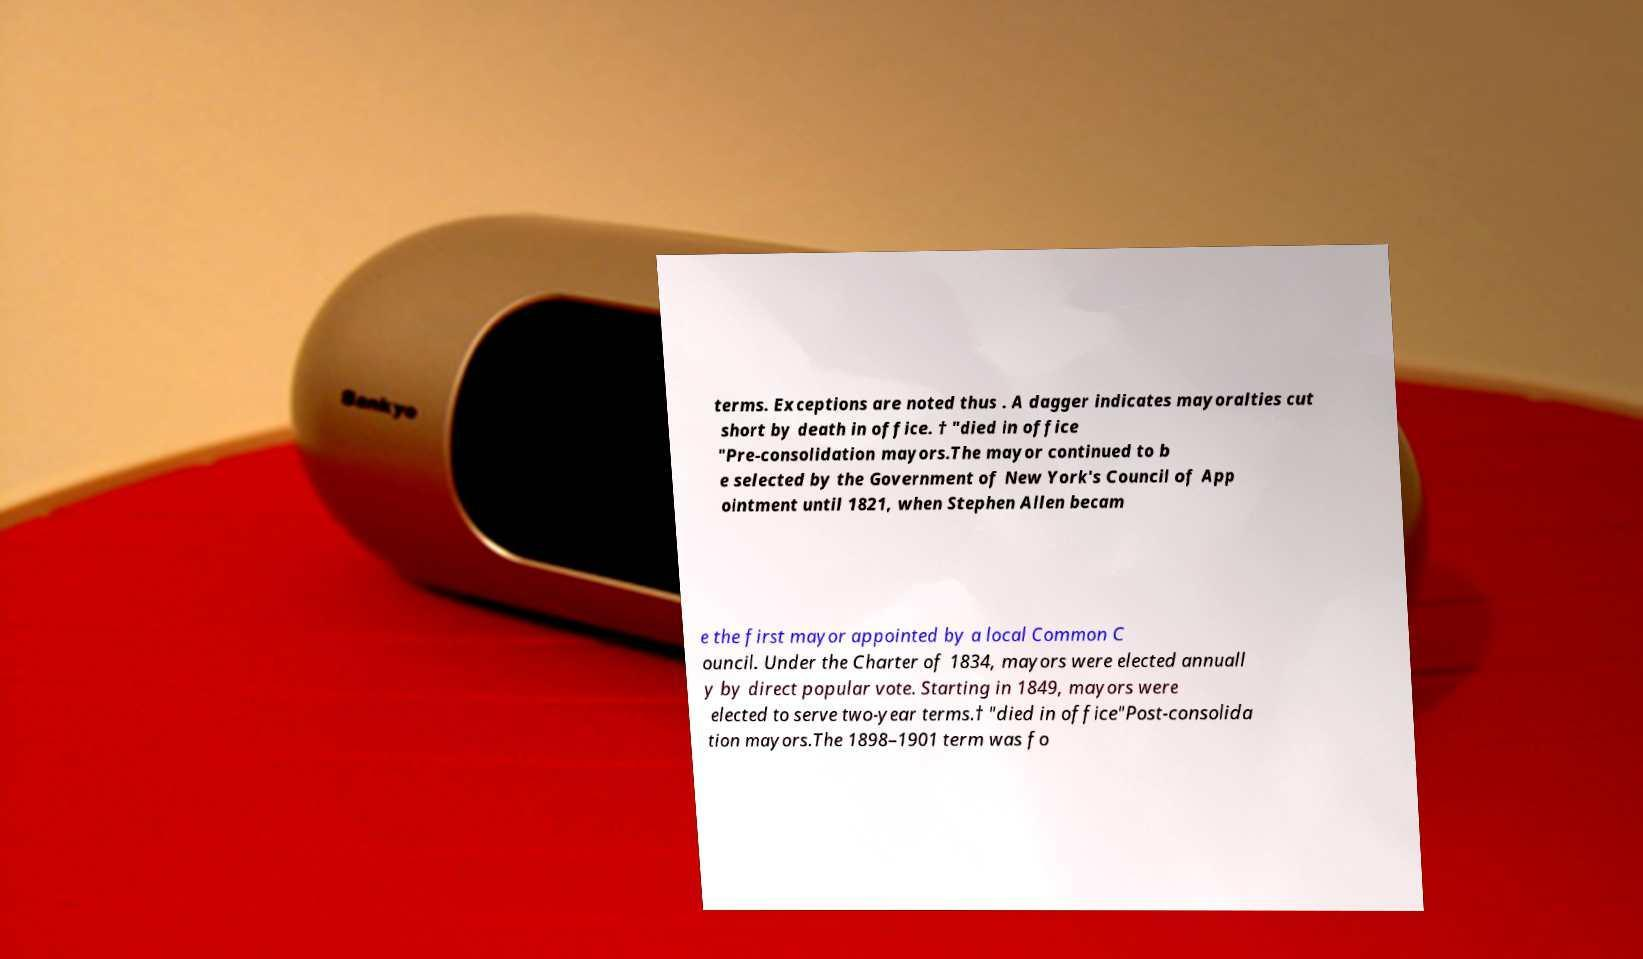Please read and relay the text visible in this image. What does it say? terms. Exceptions are noted thus . A dagger indicates mayoralties cut short by death in office. † "died in office "Pre-consolidation mayors.The mayor continued to b e selected by the Government of New York's Council of App ointment until 1821, when Stephen Allen becam e the first mayor appointed by a local Common C ouncil. Under the Charter of 1834, mayors were elected annuall y by direct popular vote. Starting in 1849, mayors were elected to serve two-year terms.† "died in office"Post-consolida tion mayors.The 1898–1901 term was fo 